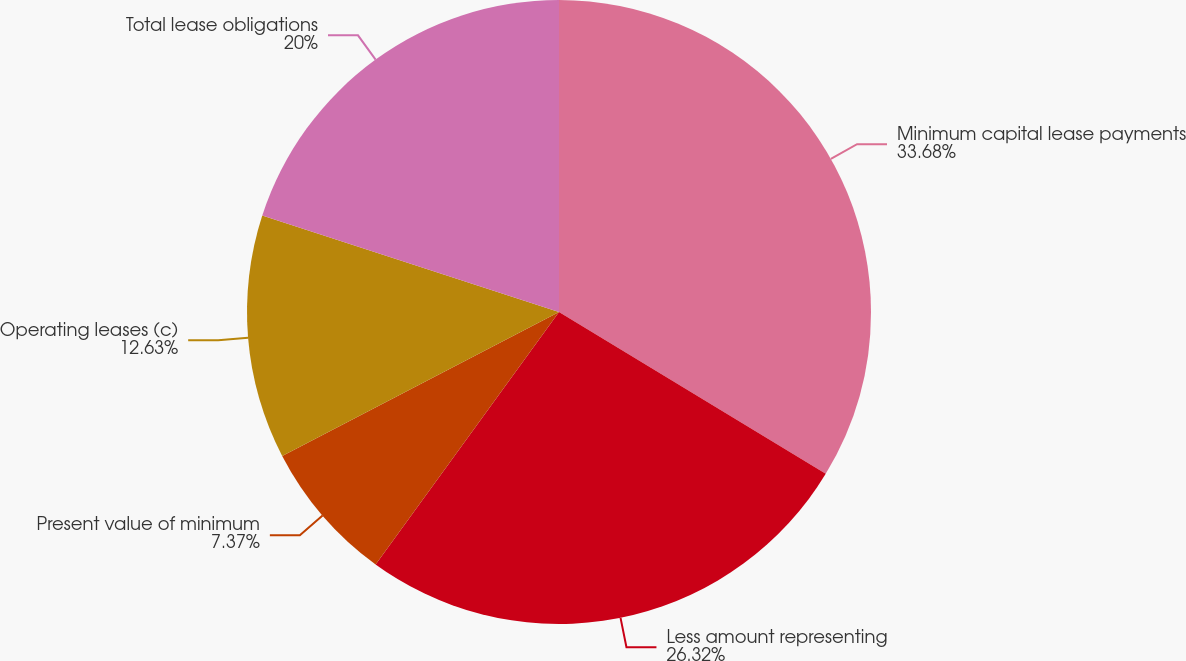Convert chart. <chart><loc_0><loc_0><loc_500><loc_500><pie_chart><fcel>Minimum capital lease payments<fcel>Less amount representing<fcel>Present value of minimum<fcel>Operating leases (c)<fcel>Total lease obligations<nl><fcel>33.68%<fcel>26.32%<fcel>7.37%<fcel>12.63%<fcel>20.0%<nl></chart> 